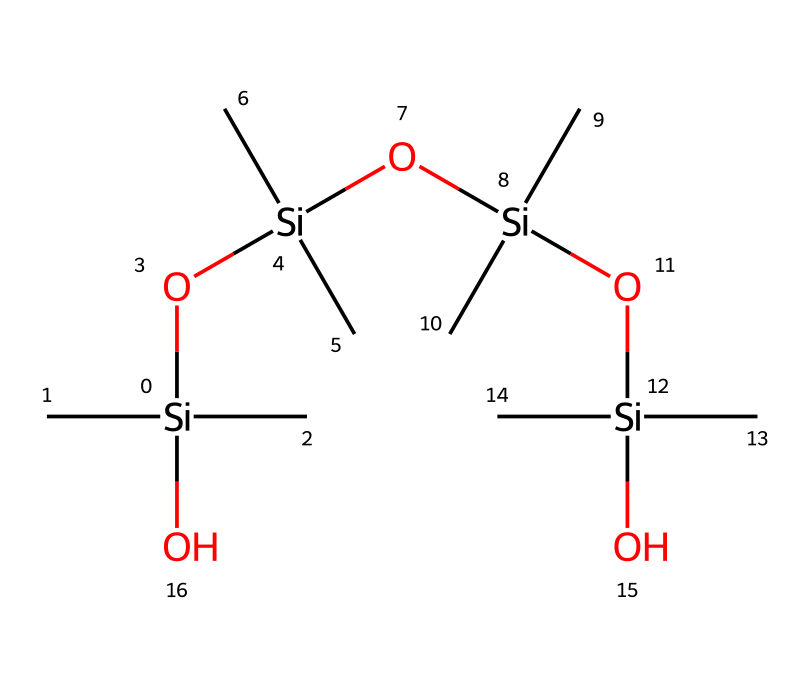What is the central atom in this chemical structure? The central atom in this organosilicon compound is silicon, represented by the symbol [Si] in the SMILES. It is crucial since it defines the compound as an organosilicon compound.
Answer: silicon How many silicon atoms are present in the structure? The SMILES indicates one central silicon atom, and there are additional silicon atoms in the chain formed by the repeating units. By counting these, there are four silicon atoms in total.
Answer: four What functional group is present in this compound? The compound contains hydroxyl groups (-OH) as indicated by the “O” attached to the silicon atoms. These functional groups contribute to the compound's adhesive and moisture-retaining properties.
Answer: hydroxyl group How many carbon atoms are found in the entire structure? Each silicon atom is bonded to two carbon atoms, and with four silicon atoms, that results in a total of eight carbon atoms. Thus, the counting of all connections confirms this fact.
Answer: eight What type of bonding is primarily present between silicon and oxygen in the structure? The bonding between silicon and oxygen in this organosilicon compound is primarily covalent bonding. This can be inferred from the connectivity shown in the SMILES representation where silicon forms direct bonds (indicated by the parentheses) with oxygen atoms.
Answer: covalent What is the effect of the hydroxyl groups on the performance of this grip enhancer? The presence of hydroxyl groups increases the hydrophilicity of the compound, enhancing grip by promoting adhesion in moist conditions. This understanding is essential when considering the performance features of sports grip enhancers.
Answer: increases adhesion 